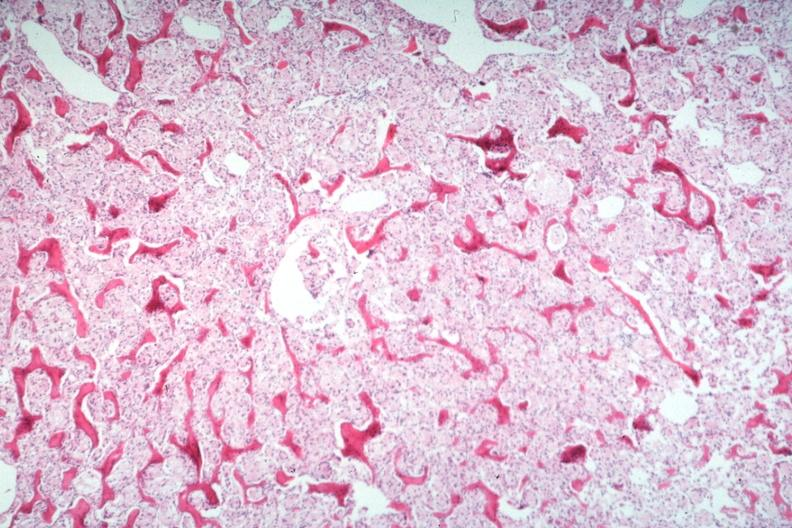what does this image show?
Answer the question using a single word or phrase. Stomach primary 